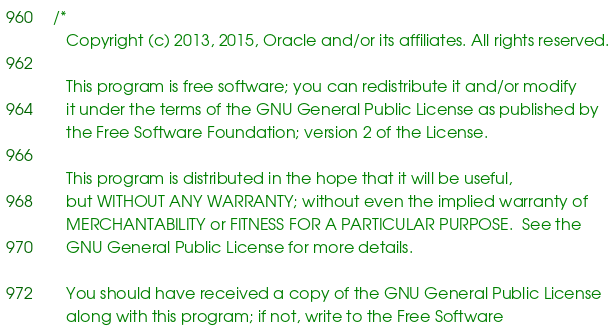Convert code to text. <code><loc_0><loc_0><loc_500><loc_500><_C++_>/*
   Copyright (c) 2013, 2015, Oracle and/or its affiliates. All rights reserved.

   This program is free software; you can redistribute it and/or modify
   it under the terms of the GNU General Public License as published by
   the Free Software Foundation; version 2 of the License.

   This program is distributed in the hope that it will be useful,
   but WITHOUT ANY WARRANTY; without even the implied warranty of
   MERCHANTABILITY or FITNESS FOR A PARTICULAR PURPOSE.  See the
   GNU General Public License for more details.

   You should have received a copy of the GNU General Public License
   along with this program; if not, write to the Free Software</code> 